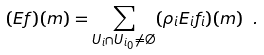Convert formula to latex. <formula><loc_0><loc_0><loc_500><loc_500>( E f ) ( m ) = \sum _ { U _ { i } \cap U _ { i _ { 0 } } \neq \emptyset } ( \rho _ { i } E _ { i } f _ { i } ) ( m ) \ .</formula> 